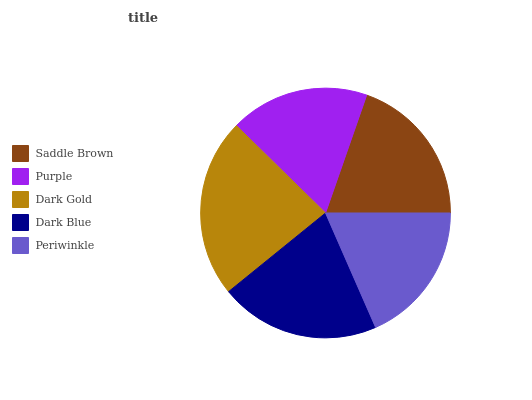Is Purple the minimum?
Answer yes or no. Yes. Is Dark Gold the maximum?
Answer yes or no. Yes. Is Dark Gold the minimum?
Answer yes or no. No. Is Purple the maximum?
Answer yes or no. No. Is Dark Gold greater than Purple?
Answer yes or no. Yes. Is Purple less than Dark Gold?
Answer yes or no. Yes. Is Purple greater than Dark Gold?
Answer yes or no. No. Is Dark Gold less than Purple?
Answer yes or no. No. Is Saddle Brown the high median?
Answer yes or no. Yes. Is Saddle Brown the low median?
Answer yes or no. Yes. Is Dark Blue the high median?
Answer yes or no. No. Is Dark Blue the low median?
Answer yes or no. No. 